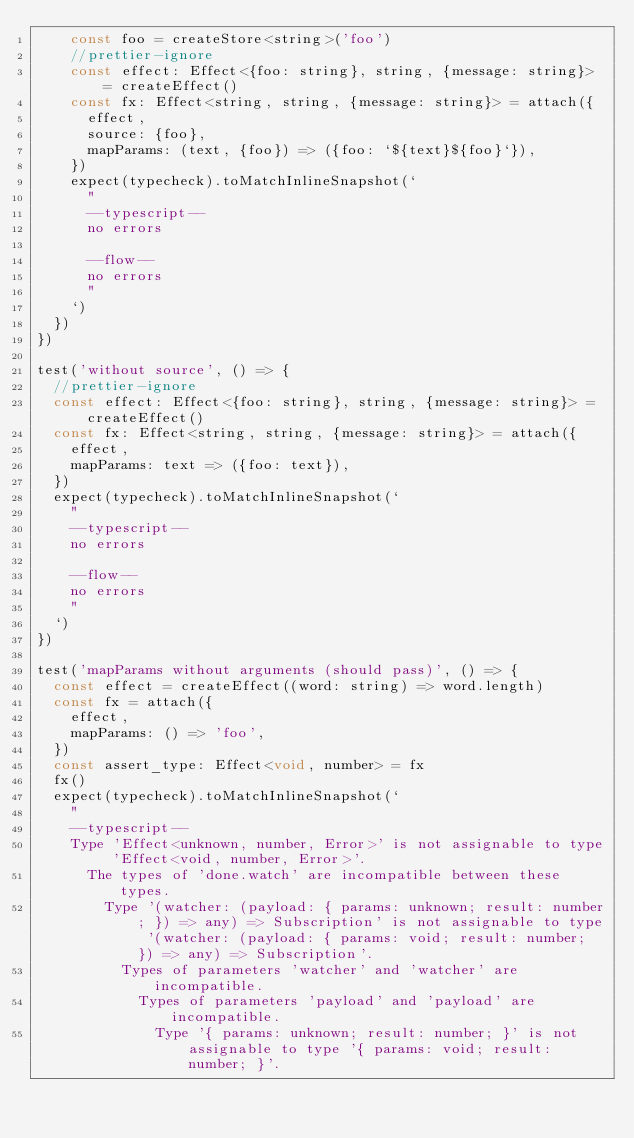Convert code to text. <code><loc_0><loc_0><loc_500><loc_500><_JavaScript_>    const foo = createStore<string>('foo')
    //prettier-ignore
    const effect: Effect<{foo: string}, string, {message: string}> = createEffect()
    const fx: Effect<string, string, {message: string}> = attach({
      effect,
      source: {foo},
      mapParams: (text, {foo}) => ({foo: `${text}${foo}`}),
    })
    expect(typecheck).toMatchInlineSnapshot(`
      "
      --typescript--
      no errors

      --flow--
      no errors
      "
    `)
  })
})

test('without source', () => {
  //prettier-ignore
  const effect: Effect<{foo: string}, string, {message: string}> = createEffect()
  const fx: Effect<string, string, {message: string}> = attach({
    effect,
    mapParams: text => ({foo: text}),
  })
  expect(typecheck).toMatchInlineSnapshot(`
    "
    --typescript--
    no errors

    --flow--
    no errors
    "
  `)
})

test('mapParams without arguments (should pass)', () => {
  const effect = createEffect((word: string) => word.length)
  const fx = attach({
    effect,
    mapParams: () => 'foo',
  })
  const assert_type: Effect<void, number> = fx
  fx()
  expect(typecheck).toMatchInlineSnapshot(`
    "
    --typescript--
    Type 'Effect<unknown, number, Error>' is not assignable to type 'Effect<void, number, Error>'.
      The types of 'done.watch' are incompatible between these types.
        Type '(watcher: (payload: { params: unknown; result: number; }) => any) => Subscription' is not assignable to type '(watcher: (payload: { params: void; result: number; }) => any) => Subscription'.
          Types of parameters 'watcher' and 'watcher' are incompatible.
            Types of parameters 'payload' and 'payload' are incompatible.
              Type '{ params: unknown; result: number; }' is not assignable to type '{ params: void; result: number; }'.</code> 